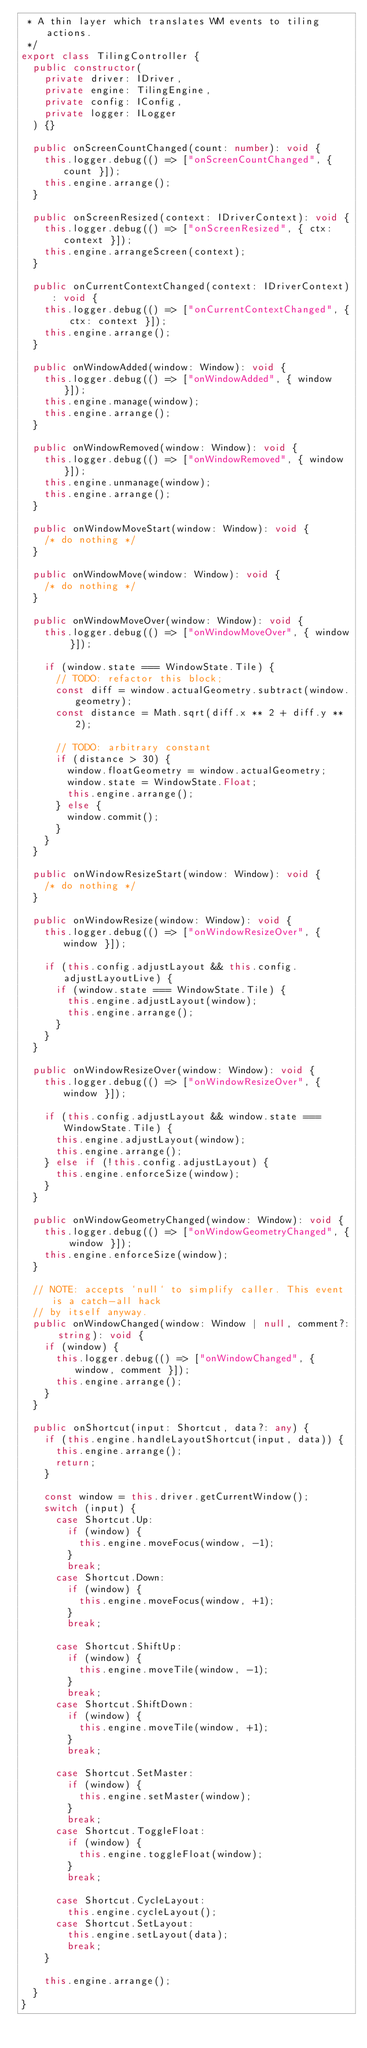<code> <loc_0><loc_0><loc_500><loc_500><_TypeScript_> * A thin layer which translates WM events to tiling actions.
 */
export class TilingController {
  public constructor(
    private driver: IDriver,
    private engine: TilingEngine,
    private config: IConfig,
    private logger: ILogger
  ) {}

  public onScreenCountChanged(count: number): void {
    this.logger.debug(() => ["onScreenCountChanged", { count }]);
    this.engine.arrange();
  }

  public onScreenResized(context: IDriverContext): void {
    this.logger.debug(() => ["onScreenResized", { ctx: context }]);
    this.engine.arrangeScreen(context);
  }

  public onCurrentContextChanged(context: IDriverContext): void {
    this.logger.debug(() => ["onCurrentContextChanged", { ctx: context }]);
    this.engine.arrange();
  }

  public onWindowAdded(window: Window): void {
    this.logger.debug(() => ["onWindowAdded", { window }]);
    this.engine.manage(window);
    this.engine.arrange();
  }

  public onWindowRemoved(window: Window): void {
    this.logger.debug(() => ["onWindowRemoved", { window }]);
    this.engine.unmanage(window);
    this.engine.arrange();
  }

  public onWindowMoveStart(window: Window): void {
    /* do nothing */
  }

  public onWindowMove(window: Window): void {
    /* do nothing */
  }

  public onWindowMoveOver(window: Window): void {
    this.logger.debug(() => ["onWindowMoveOver", { window }]);

    if (window.state === WindowState.Tile) {
      // TODO: refactor this block;
      const diff = window.actualGeometry.subtract(window.geometry);
      const distance = Math.sqrt(diff.x ** 2 + diff.y ** 2);

      // TODO: arbitrary constant
      if (distance > 30) {
        window.floatGeometry = window.actualGeometry;
        window.state = WindowState.Float;
        this.engine.arrange();
      } else {
        window.commit();
      }
    }
  }

  public onWindowResizeStart(window: Window): void {
    /* do nothing */
  }

  public onWindowResize(window: Window): void {
    this.logger.debug(() => ["onWindowResizeOver", { window }]);

    if (this.config.adjustLayout && this.config.adjustLayoutLive) {
      if (window.state === WindowState.Tile) {
        this.engine.adjustLayout(window);
        this.engine.arrange();
      }
    }
  }

  public onWindowResizeOver(window: Window): void {
    this.logger.debug(() => ["onWindowResizeOver", { window }]);

    if (this.config.adjustLayout && window.state === WindowState.Tile) {
      this.engine.adjustLayout(window);
      this.engine.arrange();
    } else if (!this.config.adjustLayout) {
      this.engine.enforceSize(window);
    }
  }

  public onWindowGeometryChanged(window: Window): void {
    this.logger.debug(() => ["onWindowGeometryChanged", { window }]);
    this.engine.enforceSize(window);
  }

  // NOTE: accepts `null` to simplify caller. This event is a catch-all hack
  // by itself anyway.
  public onWindowChanged(window: Window | null, comment?: string): void {
    if (window) {
      this.logger.debug(() => ["onWindowChanged", { window, comment }]);
      this.engine.arrange();
    }
  }

  public onShortcut(input: Shortcut, data?: any) {
    if (this.engine.handleLayoutShortcut(input, data)) {
      this.engine.arrange();
      return;
    }

    const window = this.driver.getCurrentWindow();
    switch (input) {
      case Shortcut.Up:
        if (window) {
          this.engine.moveFocus(window, -1);
        }
        break;
      case Shortcut.Down:
        if (window) {
          this.engine.moveFocus(window, +1);
        }
        break;

      case Shortcut.ShiftUp:
        if (window) {
          this.engine.moveTile(window, -1);
        }
        break;
      case Shortcut.ShiftDown:
        if (window) {
          this.engine.moveTile(window, +1);
        }
        break;

      case Shortcut.SetMaster:
        if (window) {
          this.engine.setMaster(window);
        }
        break;
      case Shortcut.ToggleFloat:
        if (window) {
          this.engine.toggleFloat(window);
        }
        break;

      case Shortcut.CycleLayout:
        this.engine.cycleLayout();
      case Shortcut.SetLayout:
        this.engine.setLayout(data);
        break;
    }

    this.engine.arrange();
  }
}
</code> 